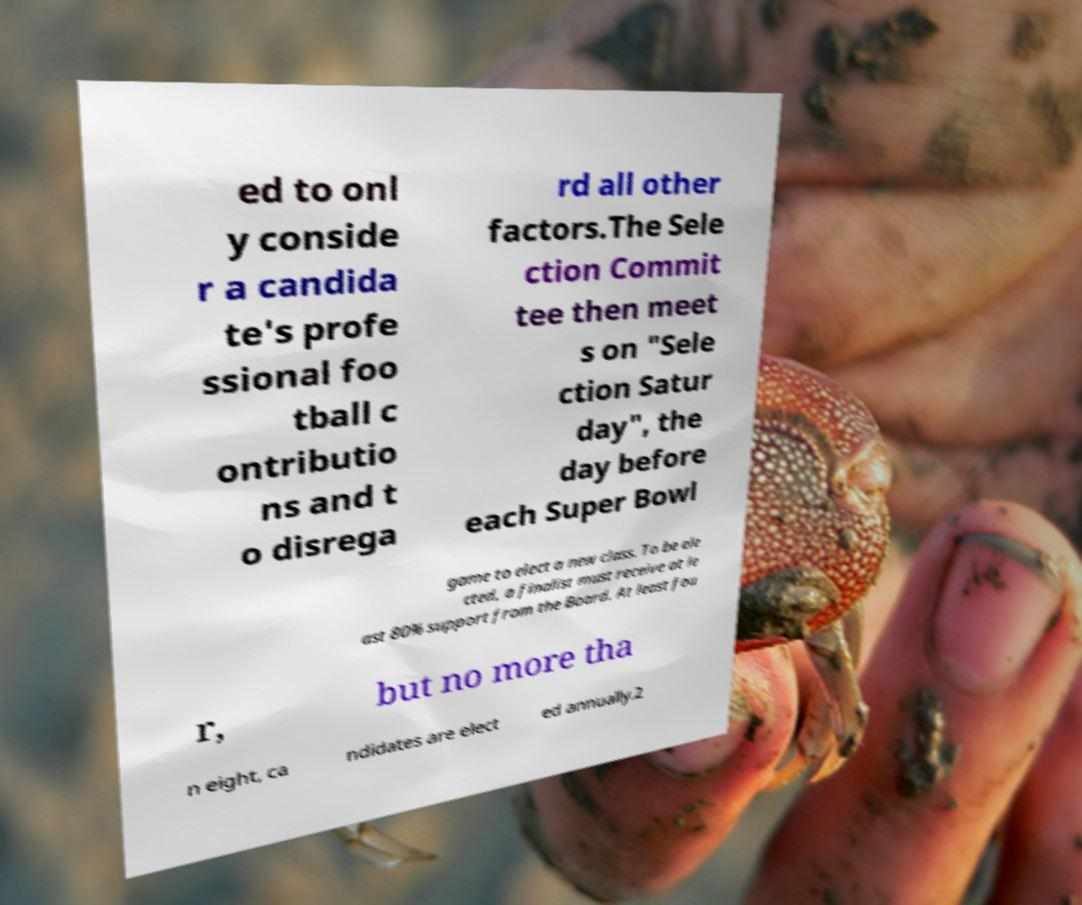What messages or text are displayed in this image? I need them in a readable, typed format. ed to onl y conside r a candida te's profe ssional foo tball c ontributio ns and t o disrega rd all other factors.The Sele ction Commit tee then meet s on "Sele ction Satur day", the day before each Super Bowl game to elect a new class. To be ele cted, a finalist must receive at le ast 80% support from the Board. At least fou r, but no more tha n eight, ca ndidates are elect ed annually.2 